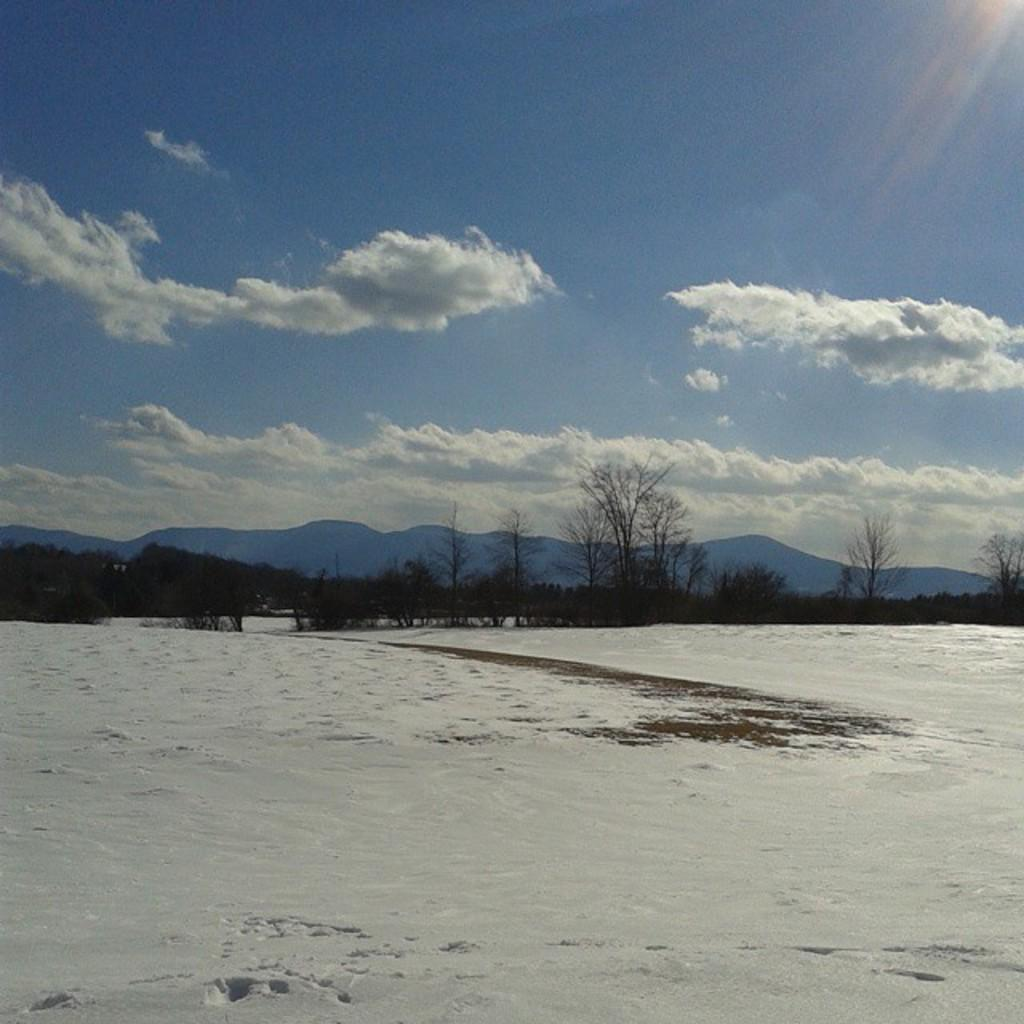What is covering the ground in the image? There is snow on the ground in the image. What can be seen in the distance behind the snow-covered ground? There are trees and mountains visible in the background of the image. What is the condition of the sky in the image? The sky is cloudy in the image. What type of pencil can be seen in the image? There is no pencil present in the image. How does the lettuce look in the image? There is no lettuce present in the image. 